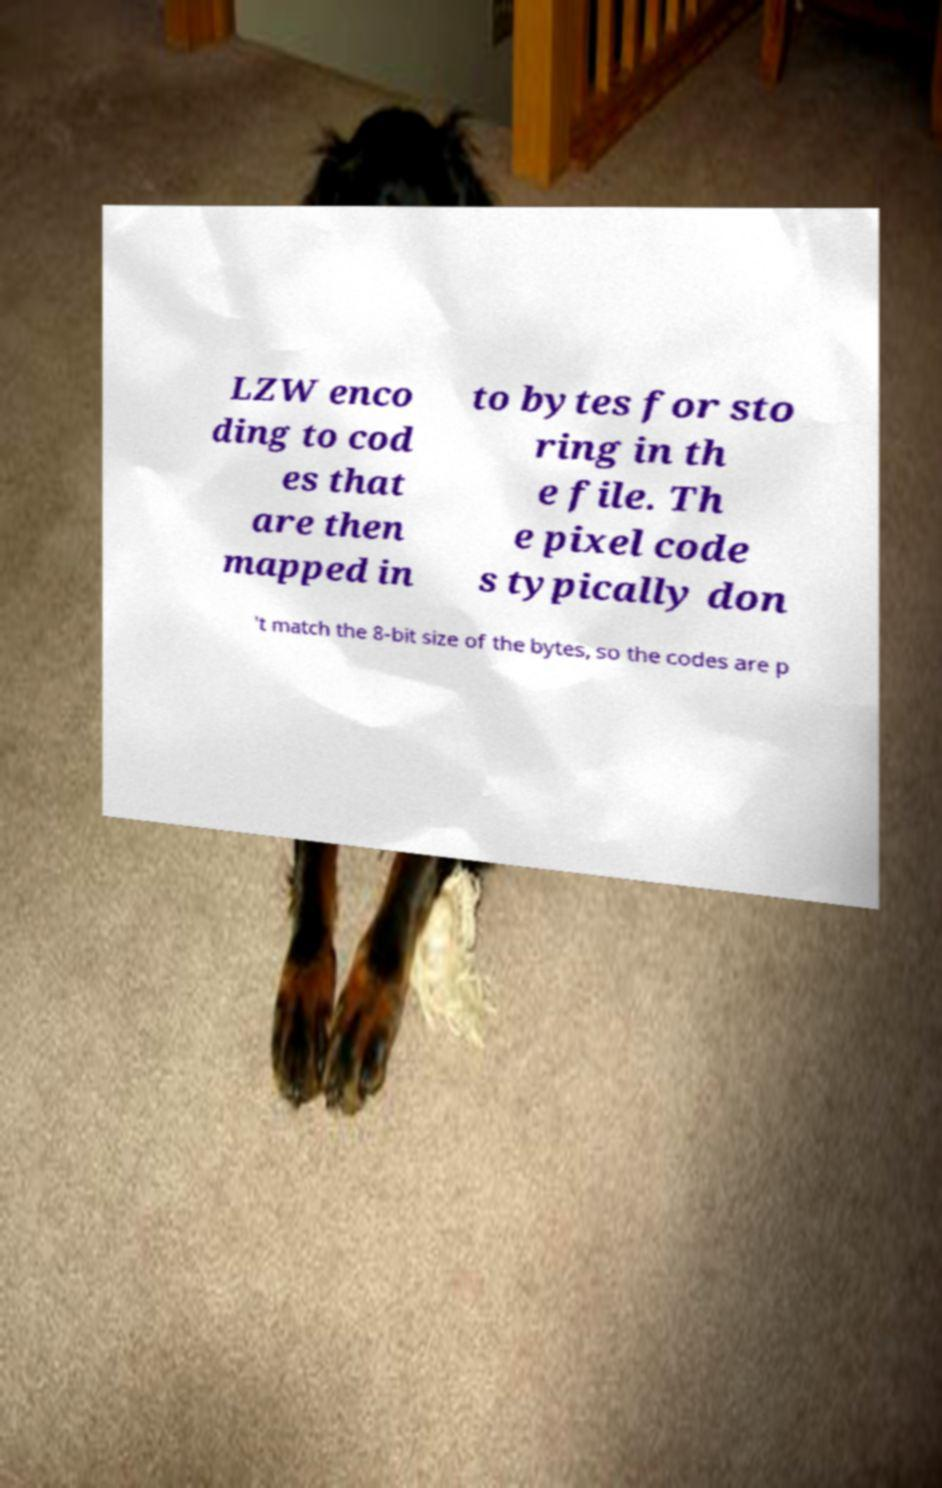Please identify and transcribe the text found in this image. LZW enco ding to cod es that are then mapped in to bytes for sto ring in th e file. Th e pixel code s typically don 't match the 8-bit size of the bytes, so the codes are p 